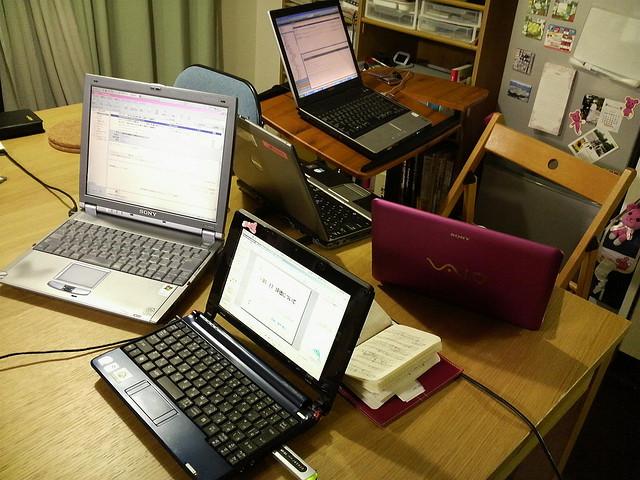How many laptops are closed in this photo?
Quick response, please. 0. What color is the Sony vaio?
Concise answer only. Purple. What is the table made of?
Short answer required. Wood. 